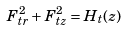Convert formula to latex. <formula><loc_0><loc_0><loc_500><loc_500>F _ { t r } ^ { 2 } + F _ { t z } ^ { 2 } = H _ { t } ( z )</formula> 